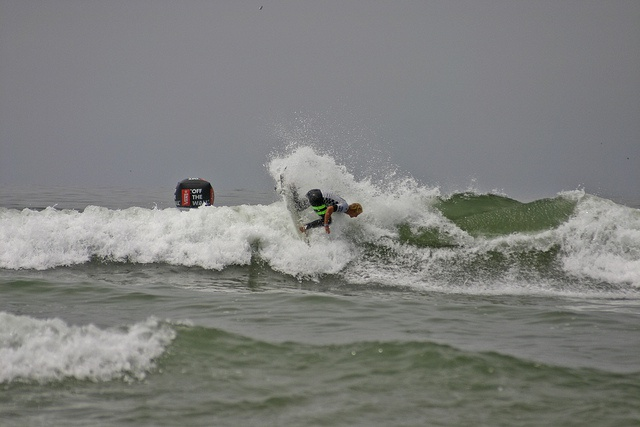Describe the objects in this image and their specific colors. I can see people in gray, black, darkgray, and maroon tones and surfboard in gray and darkgray tones in this image. 